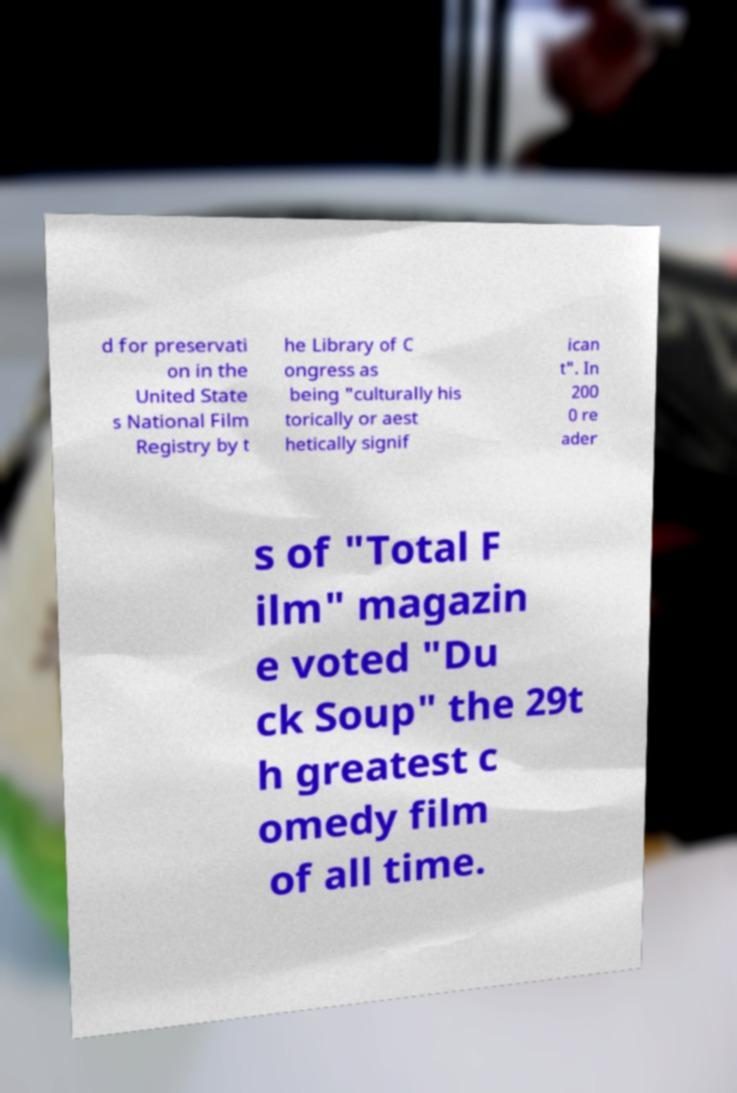Please read and relay the text visible in this image. What does it say? d for preservati on in the United State s National Film Registry by t he Library of C ongress as being "culturally his torically or aest hetically signif ican t". In 200 0 re ader s of "Total F ilm" magazin e voted "Du ck Soup" the 29t h greatest c omedy film of all time. 